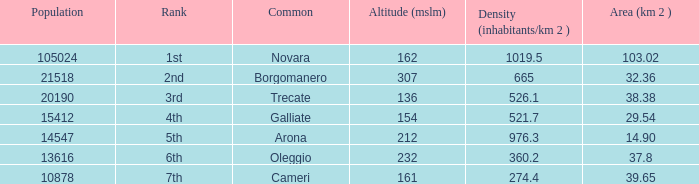Where does the common of Galliate rank in population? 4th. 